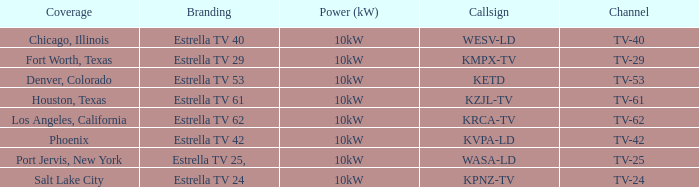List the power output for Phoenix.  10kW. 